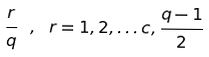Convert formula to latex. <formula><loc_0><loc_0><loc_500><loc_500>\frac { r } { q } \ , \ r = 1 , 2 , \dots c , \frac { q - 1 } { 2 }</formula> 